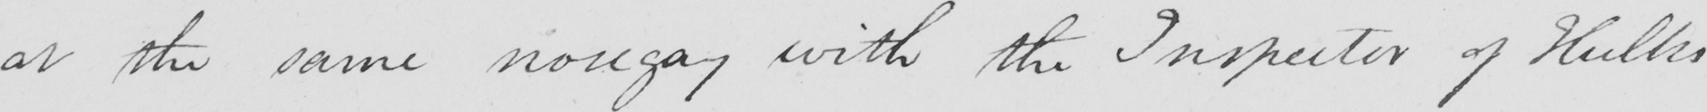What text is written in this handwritten line? at the same nosegay with the Inspector of Hulks 